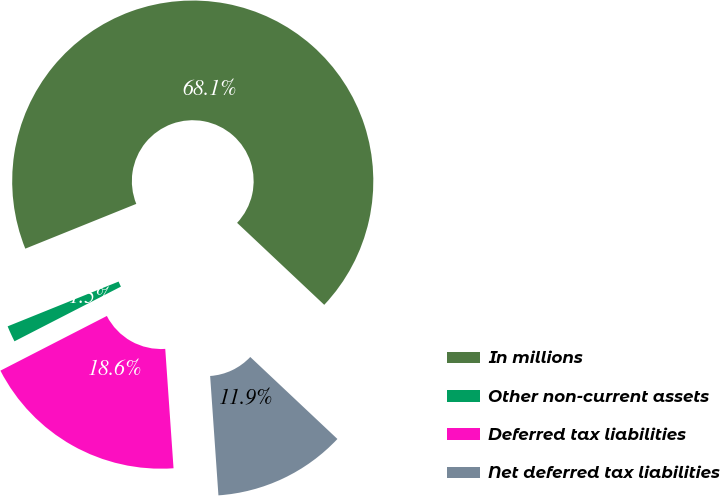Convert chart to OTSL. <chart><loc_0><loc_0><loc_500><loc_500><pie_chart><fcel>In millions<fcel>Other non-current assets<fcel>Deferred tax liabilities<fcel>Net deferred tax liabilities<nl><fcel>68.12%<fcel>1.45%<fcel>18.55%<fcel>11.88%<nl></chart> 